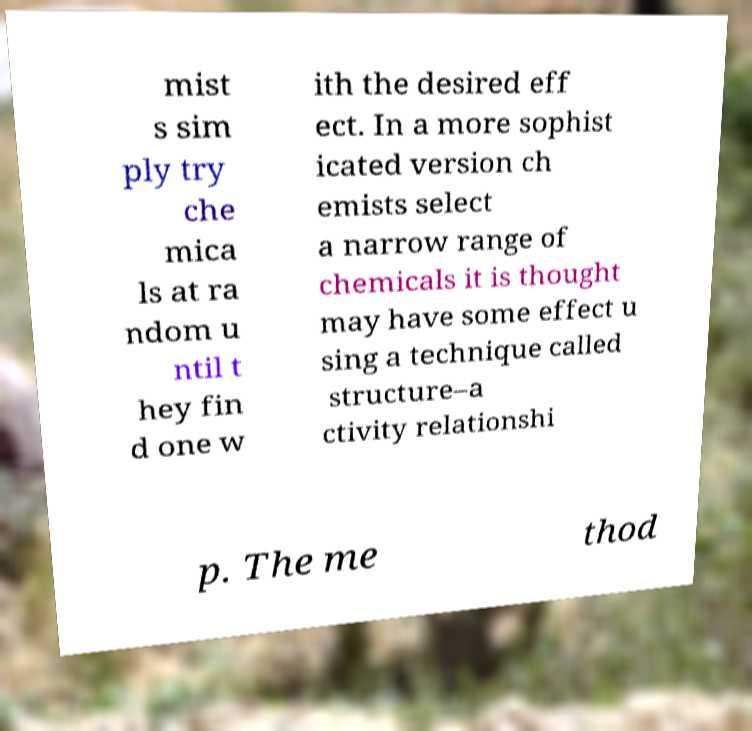There's text embedded in this image that I need extracted. Can you transcribe it verbatim? mist s sim ply try che mica ls at ra ndom u ntil t hey fin d one w ith the desired eff ect. In a more sophist icated version ch emists select a narrow range of chemicals it is thought may have some effect u sing a technique called structure–a ctivity relationshi p. The me thod 